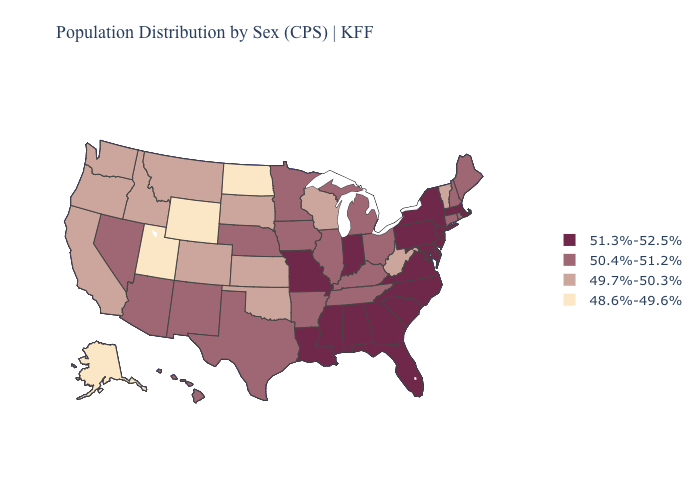Is the legend a continuous bar?
Short answer required. No. Which states hav the highest value in the South?
Keep it brief. Alabama, Delaware, Florida, Georgia, Louisiana, Maryland, Mississippi, North Carolina, South Carolina, Virginia. What is the lowest value in the USA?
Write a very short answer. 48.6%-49.6%. Among the states that border Kansas , does Missouri have the lowest value?
Concise answer only. No. Does the map have missing data?
Quick response, please. No. What is the highest value in the USA?
Be succinct. 51.3%-52.5%. What is the lowest value in states that border Iowa?
Keep it brief. 49.7%-50.3%. What is the highest value in states that border New Hampshire?
Short answer required. 51.3%-52.5%. Name the states that have a value in the range 49.7%-50.3%?
Keep it brief. California, Colorado, Idaho, Kansas, Montana, Oklahoma, Oregon, South Dakota, Vermont, Washington, West Virginia, Wisconsin. Name the states that have a value in the range 49.7%-50.3%?
Short answer required. California, Colorado, Idaho, Kansas, Montana, Oklahoma, Oregon, South Dakota, Vermont, Washington, West Virginia, Wisconsin. How many symbols are there in the legend?
Be succinct. 4. Name the states that have a value in the range 48.6%-49.6%?
Concise answer only. Alaska, North Dakota, Utah, Wyoming. What is the value of Texas?
Short answer required. 50.4%-51.2%. What is the lowest value in states that border Alabama?
Concise answer only. 50.4%-51.2%. What is the value of Texas?
Quick response, please. 50.4%-51.2%. 